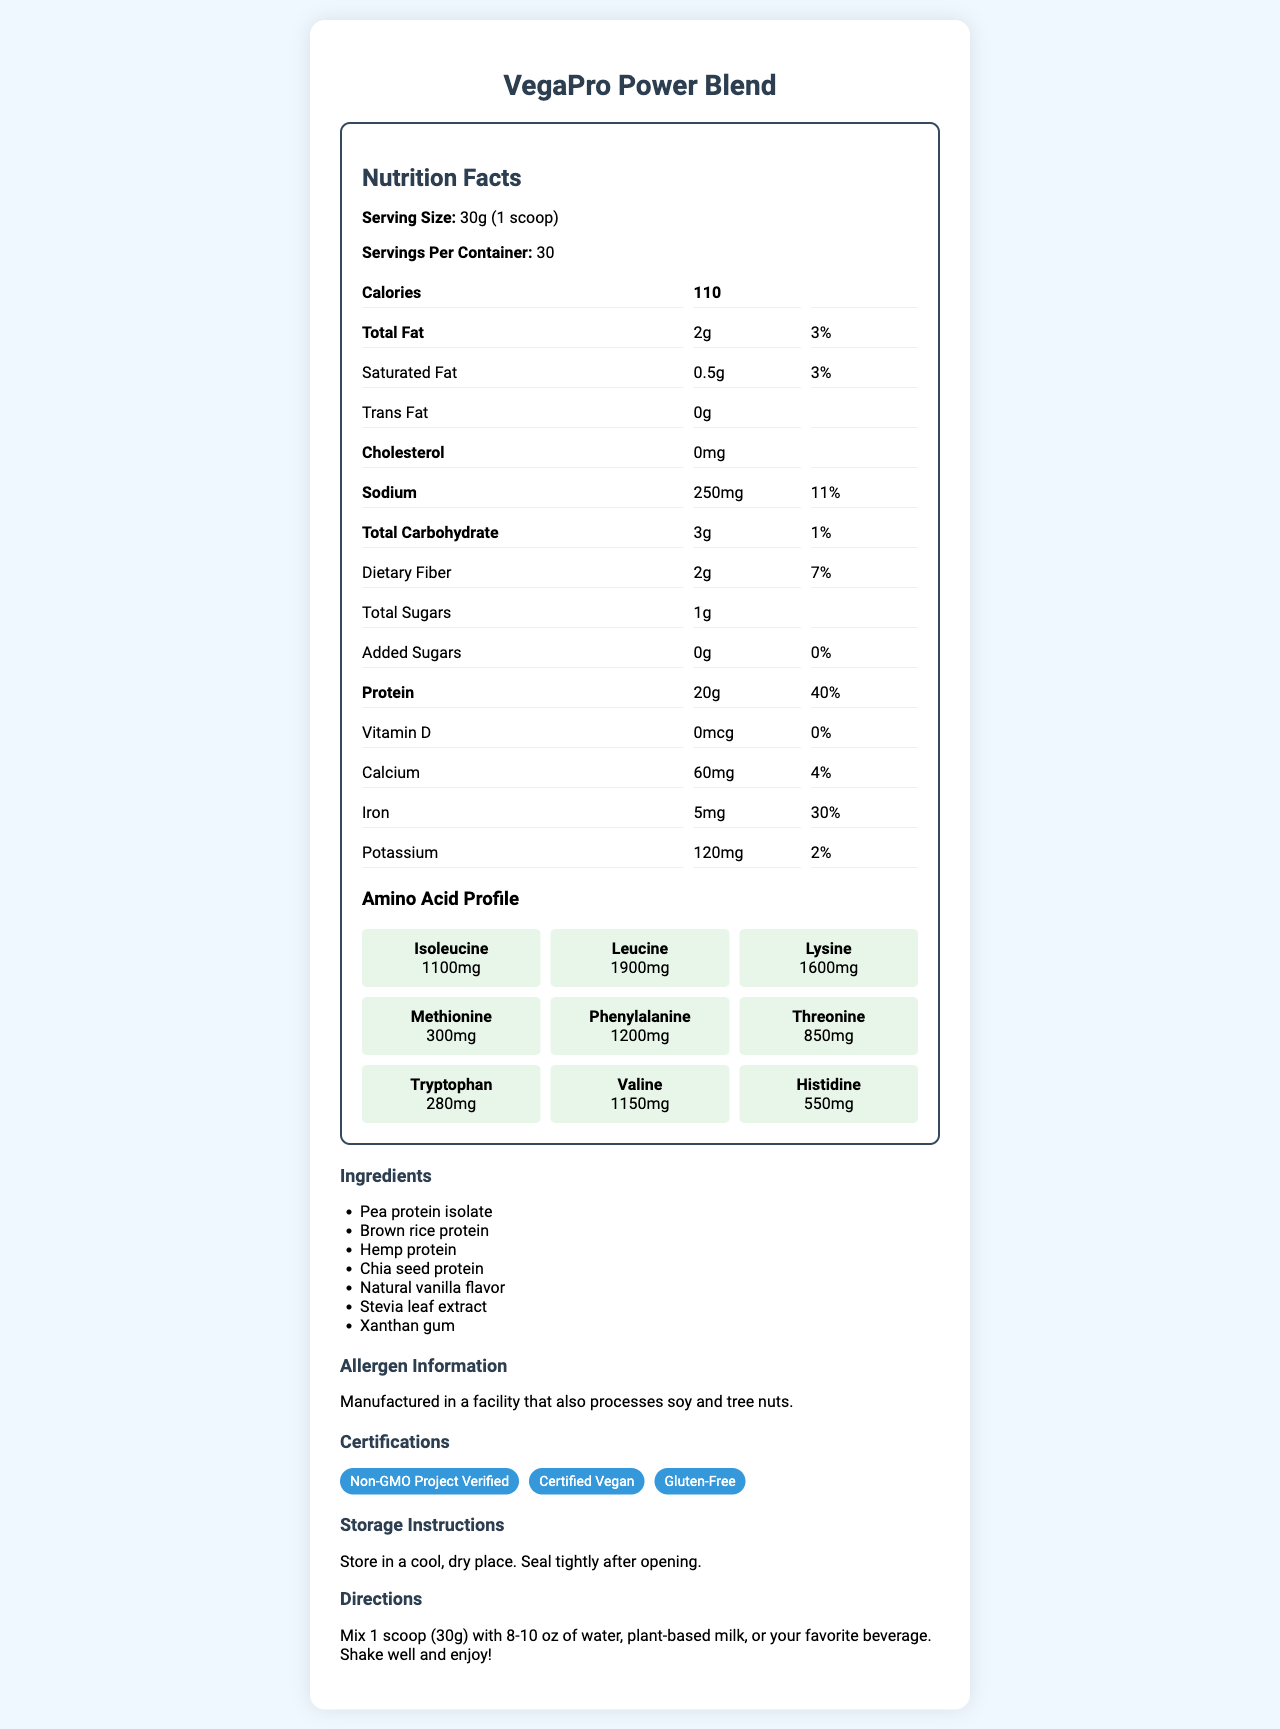what is the serving size of VegaPro Power Blend? The serving size is explicitly mentioned as "30g (1 scoop)" in the document.
Answer: 30g (1 scoop) how many servings are there in one container of VegaPro Power Blend? The number of servings per container is listed as 30.
Answer: 30 how many grams of protein does one serving contain? According to the document, each serving contains 20g of protein.
Answer: 20g what percentage of the daily value for iron does one serving provide? The daily value for iron in one serving is listed as 30%.
Answer: 30% what is the total fat content in grams per serving? The document states that the total fat content per serving is 2g.
Answer: 2g which ingredient is not part of VegaPro Power Blend? A. Pea protein isolate B. Whey protein C. Hemp protein D. Chia seed protein Whey protein is not listed in the ingredients.
Answer: B which of the following certifications does VegaPro Power Blend have? A. Certified Organic B. Non-GMO Project Verified C. Halal The certifications include "Non-GMO Project Verified," "Certified Vegan," and "Gluten-Free," but not "Certified Organic" or "Halal."
Answer: B is this product gluten-free? The document lists "Gluten-Free" as one of the certifications.
Answer: Yes summarize the main features of VegaPro Power Blend as described in the document. The document provides detailed nutritional information, certifications, and directions for use, aiming to inform users about the product's high protein content, health benefits, and dietary suitability.
Answer: VegaPro Power Blend is a vegan protein powder with a serving size of 30g, containing 20g of protein, 2g of total fat, and 110 calories per serving. It includes an amino acid profile and is certified Non-GMO, Vegan, and Gluten-Free. The ingredients include pea protein isolate, brown rice protein, and more. The product has specific storage and mixing instructions. what is the daily value percentage of sodium per serving? The document states the daily value percentage for sodium as 11%.
Answer: 11% how much lysine is present in the amino acid profile per serving? The amino acid profile lists lysine as containing 1600mg per serving.
Answer: 1600mg how should the product be stored after opening? The document explicitly advises to store the product in a cool, dry place and seal it tightly after opening.
Answer: Store in a cool, dry place. Seal tightly after opening. what is the main flavoring agent in VegaPro Power Blend? The ingredients list includes "Natural vanilla flavor" as the flavoring agent.
Answer: Natural vanilla flavor how many grams of dietary fiber are in each serving? Each serving contains 2g of dietary fiber as listed in the document.
Answer: 2g is VegaPro Power Blend suitable for people allergic to soy or tree nuts? The allergen information states that it is manufactured in a facility that also processes soy and tree nuts, but it doesn't confirm if it is suitable or not for those allergic.
Answer: Not enough information does VegaPro Power Blend contain any cholesterol? The document specifies that the cholesterol content is 0mg.
Answer: No 